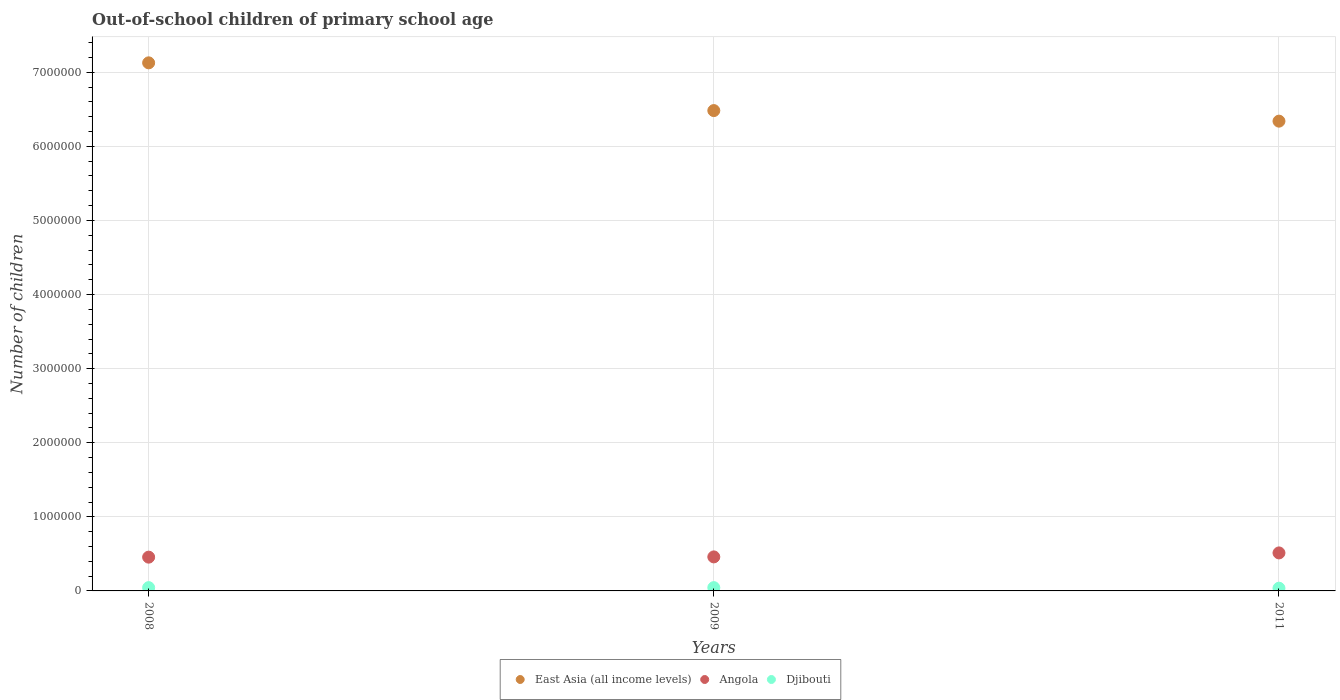What is the number of out-of-school children in East Asia (all income levels) in 2011?
Provide a short and direct response. 6.34e+06. Across all years, what is the maximum number of out-of-school children in Djibouti?
Your answer should be compact. 4.44e+04. Across all years, what is the minimum number of out-of-school children in Angola?
Keep it short and to the point. 4.56e+05. In which year was the number of out-of-school children in Angola maximum?
Offer a terse response. 2011. What is the total number of out-of-school children in East Asia (all income levels) in the graph?
Offer a terse response. 2.00e+07. What is the difference between the number of out-of-school children in Djibouti in 2008 and that in 2011?
Ensure brevity in your answer.  7635. What is the difference between the number of out-of-school children in Angola in 2011 and the number of out-of-school children in East Asia (all income levels) in 2009?
Offer a terse response. -5.97e+06. What is the average number of out-of-school children in Angola per year?
Offer a very short reply. 4.76e+05. In the year 2011, what is the difference between the number of out-of-school children in Djibouti and number of out-of-school children in Angola?
Provide a short and direct response. -4.76e+05. What is the ratio of the number of out-of-school children in Angola in 2009 to that in 2011?
Keep it short and to the point. 0.9. Is the number of out-of-school children in Angola in 2009 less than that in 2011?
Offer a very short reply. Yes. Is the difference between the number of out-of-school children in Djibouti in 2008 and 2011 greater than the difference between the number of out-of-school children in Angola in 2008 and 2011?
Your answer should be compact. Yes. What is the difference between the highest and the second highest number of out-of-school children in East Asia (all income levels)?
Provide a succinct answer. 6.44e+05. What is the difference between the highest and the lowest number of out-of-school children in Angola?
Ensure brevity in your answer.  5.71e+04. Is the sum of the number of out-of-school children in Angola in 2008 and 2011 greater than the maximum number of out-of-school children in Djibouti across all years?
Your response must be concise. Yes. Is it the case that in every year, the sum of the number of out-of-school children in Djibouti and number of out-of-school children in Angola  is greater than the number of out-of-school children in East Asia (all income levels)?
Ensure brevity in your answer.  No. Does the number of out-of-school children in East Asia (all income levels) monotonically increase over the years?
Provide a short and direct response. No. Is the number of out-of-school children in East Asia (all income levels) strictly greater than the number of out-of-school children in Djibouti over the years?
Ensure brevity in your answer.  Yes. Is the number of out-of-school children in Djibouti strictly less than the number of out-of-school children in East Asia (all income levels) over the years?
Keep it short and to the point. Yes. How many dotlines are there?
Your answer should be very brief. 3. How many years are there in the graph?
Ensure brevity in your answer.  3. What is the difference between two consecutive major ticks on the Y-axis?
Your answer should be very brief. 1.00e+06. Does the graph contain any zero values?
Keep it short and to the point. No. How many legend labels are there?
Your answer should be very brief. 3. What is the title of the graph?
Keep it short and to the point. Out-of-school children of primary school age. What is the label or title of the Y-axis?
Provide a succinct answer. Number of children. What is the Number of children in East Asia (all income levels) in 2008?
Your answer should be compact. 7.13e+06. What is the Number of children of Angola in 2008?
Make the answer very short. 4.56e+05. What is the Number of children in Djibouti in 2008?
Your response must be concise. 4.44e+04. What is the Number of children in East Asia (all income levels) in 2009?
Offer a very short reply. 6.48e+06. What is the Number of children of Angola in 2009?
Your answer should be compact. 4.59e+05. What is the Number of children of Djibouti in 2009?
Your answer should be compact. 4.44e+04. What is the Number of children of East Asia (all income levels) in 2011?
Ensure brevity in your answer.  6.34e+06. What is the Number of children in Angola in 2011?
Provide a short and direct response. 5.13e+05. What is the Number of children of Djibouti in 2011?
Give a very brief answer. 3.68e+04. Across all years, what is the maximum Number of children in East Asia (all income levels)?
Your answer should be compact. 7.13e+06. Across all years, what is the maximum Number of children of Angola?
Your answer should be very brief. 5.13e+05. Across all years, what is the maximum Number of children in Djibouti?
Offer a terse response. 4.44e+04. Across all years, what is the minimum Number of children in East Asia (all income levels)?
Your answer should be compact. 6.34e+06. Across all years, what is the minimum Number of children of Angola?
Your response must be concise. 4.56e+05. Across all years, what is the minimum Number of children of Djibouti?
Provide a short and direct response. 3.68e+04. What is the total Number of children in East Asia (all income levels) in the graph?
Your response must be concise. 2.00e+07. What is the total Number of children in Angola in the graph?
Provide a succinct answer. 1.43e+06. What is the total Number of children in Djibouti in the graph?
Your answer should be very brief. 1.26e+05. What is the difference between the Number of children of East Asia (all income levels) in 2008 and that in 2009?
Offer a very short reply. 6.44e+05. What is the difference between the Number of children of Angola in 2008 and that in 2009?
Your answer should be compact. -3388. What is the difference between the Number of children in Djibouti in 2008 and that in 2009?
Keep it short and to the point. -30. What is the difference between the Number of children of East Asia (all income levels) in 2008 and that in 2011?
Provide a succinct answer. 7.87e+05. What is the difference between the Number of children of Angola in 2008 and that in 2011?
Your answer should be compact. -5.71e+04. What is the difference between the Number of children in Djibouti in 2008 and that in 2011?
Give a very brief answer. 7635. What is the difference between the Number of children of East Asia (all income levels) in 2009 and that in 2011?
Give a very brief answer. 1.43e+05. What is the difference between the Number of children of Angola in 2009 and that in 2011?
Your answer should be compact. -5.38e+04. What is the difference between the Number of children in Djibouti in 2009 and that in 2011?
Provide a succinct answer. 7665. What is the difference between the Number of children in East Asia (all income levels) in 2008 and the Number of children in Angola in 2009?
Make the answer very short. 6.67e+06. What is the difference between the Number of children in East Asia (all income levels) in 2008 and the Number of children in Djibouti in 2009?
Offer a very short reply. 7.08e+06. What is the difference between the Number of children in Angola in 2008 and the Number of children in Djibouti in 2009?
Make the answer very short. 4.11e+05. What is the difference between the Number of children in East Asia (all income levels) in 2008 and the Number of children in Angola in 2011?
Offer a terse response. 6.61e+06. What is the difference between the Number of children in East Asia (all income levels) in 2008 and the Number of children in Djibouti in 2011?
Your answer should be very brief. 7.09e+06. What is the difference between the Number of children of Angola in 2008 and the Number of children of Djibouti in 2011?
Your answer should be very brief. 4.19e+05. What is the difference between the Number of children in East Asia (all income levels) in 2009 and the Number of children in Angola in 2011?
Your answer should be compact. 5.97e+06. What is the difference between the Number of children of East Asia (all income levels) in 2009 and the Number of children of Djibouti in 2011?
Offer a terse response. 6.45e+06. What is the difference between the Number of children in Angola in 2009 and the Number of children in Djibouti in 2011?
Provide a short and direct response. 4.22e+05. What is the average Number of children of East Asia (all income levels) per year?
Offer a very short reply. 6.65e+06. What is the average Number of children in Angola per year?
Your answer should be very brief. 4.76e+05. What is the average Number of children of Djibouti per year?
Your response must be concise. 4.19e+04. In the year 2008, what is the difference between the Number of children in East Asia (all income levels) and Number of children in Angola?
Make the answer very short. 6.67e+06. In the year 2008, what is the difference between the Number of children of East Asia (all income levels) and Number of children of Djibouti?
Provide a succinct answer. 7.08e+06. In the year 2008, what is the difference between the Number of children in Angola and Number of children in Djibouti?
Your response must be concise. 4.11e+05. In the year 2009, what is the difference between the Number of children of East Asia (all income levels) and Number of children of Angola?
Ensure brevity in your answer.  6.02e+06. In the year 2009, what is the difference between the Number of children of East Asia (all income levels) and Number of children of Djibouti?
Give a very brief answer. 6.44e+06. In the year 2009, what is the difference between the Number of children in Angola and Number of children in Djibouti?
Make the answer very short. 4.15e+05. In the year 2011, what is the difference between the Number of children of East Asia (all income levels) and Number of children of Angola?
Your answer should be compact. 5.83e+06. In the year 2011, what is the difference between the Number of children of East Asia (all income levels) and Number of children of Djibouti?
Provide a short and direct response. 6.30e+06. In the year 2011, what is the difference between the Number of children in Angola and Number of children in Djibouti?
Your response must be concise. 4.76e+05. What is the ratio of the Number of children of East Asia (all income levels) in 2008 to that in 2009?
Your response must be concise. 1.1. What is the ratio of the Number of children of Angola in 2008 to that in 2009?
Offer a terse response. 0.99. What is the ratio of the Number of children of East Asia (all income levels) in 2008 to that in 2011?
Keep it short and to the point. 1.12. What is the ratio of the Number of children of Angola in 2008 to that in 2011?
Your response must be concise. 0.89. What is the ratio of the Number of children of Djibouti in 2008 to that in 2011?
Offer a terse response. 1.21. What is the ratio of the Number of children in East Asia (all income levels) in 2009 to that in 2011?
Your answer should be very brief. 1.02. What is the ratio of the Number of children of Angola in 2009 to that in 2011?
Keep it short and to the point. 0.9. What is the ratio of the Number of children of Djibouti in 2009 to that in 2011?
Make the answer very short. 1.21. What is the difference between the highest and the second highest Number of children of East Asia (all income levels)?
Give a very brief answer. 6.44e+05. What is the difference between the highest and the second highest Number of children of Angola?
Ensure brevity in your answer.  5.38e+04. What is the difference between the highest and the lowest Number of children of East Asia (all income levels)?
Your answer should be compact. 7.87e+05. What is the difference between the highest and the lowest Number of children in Angola?
Provide a short and direct response. 5.71e+04. What is the difference between the highest and the lowest Number of children in Djibouti?
Offer a very short reply. 7665. 